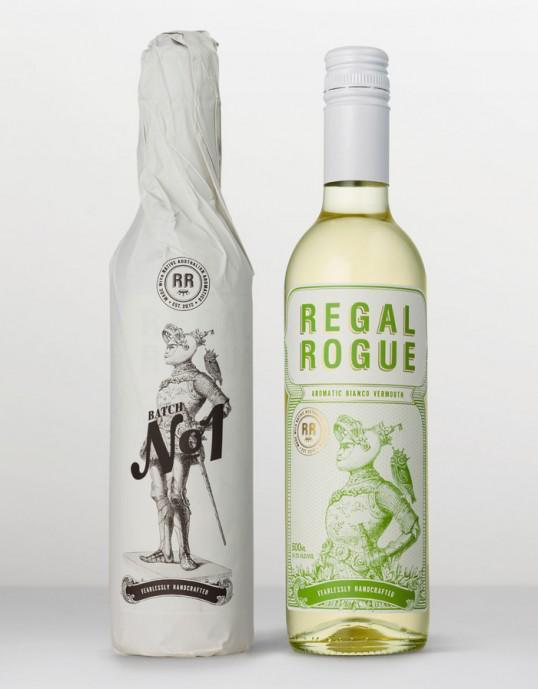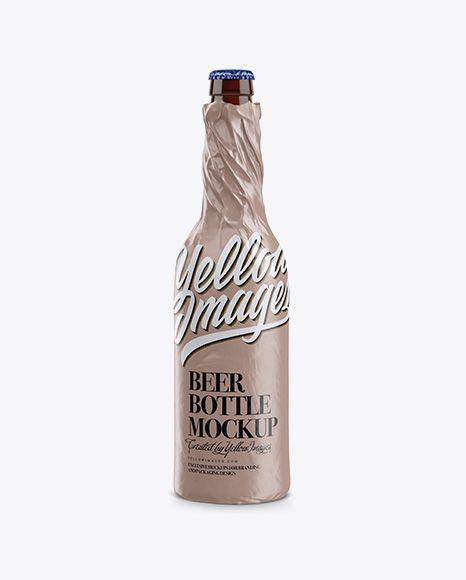The first image is the image on the left, the second image is the image on the right. Analyze the images presented: Is the assertion "There are exactly two bottles wrapped in paper." valid? Answer yes or no. Yes. 